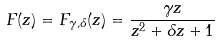<formula> <loc_0><loc_0><loc_500><loc_500>F ( z ) = F _ { \gamma , \delta } ( z ) = \frac { \gamma z } { z ^ { 2 } + \delta z + 1 }</formula> 